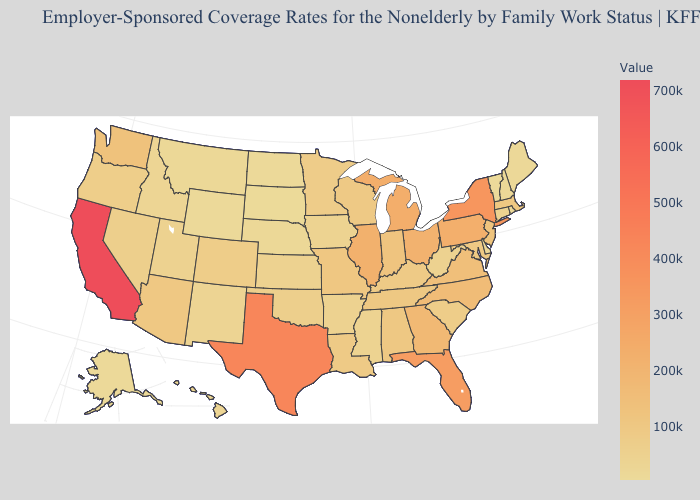Does California have the highest value in the USA?
Answer briefly. Yes. Does Michigan have a higher value than California?
Quick response, please. No. Does Vermont have the lowest value in the USA?
Short answer required. Yes. Does Wyoming have the lowest value in the West?
Short answer required. Yes. Does the map have missing data?
Give a very brief answer. No. Among the states that border Nevada , which have the highest value?
Short answer required. California. 